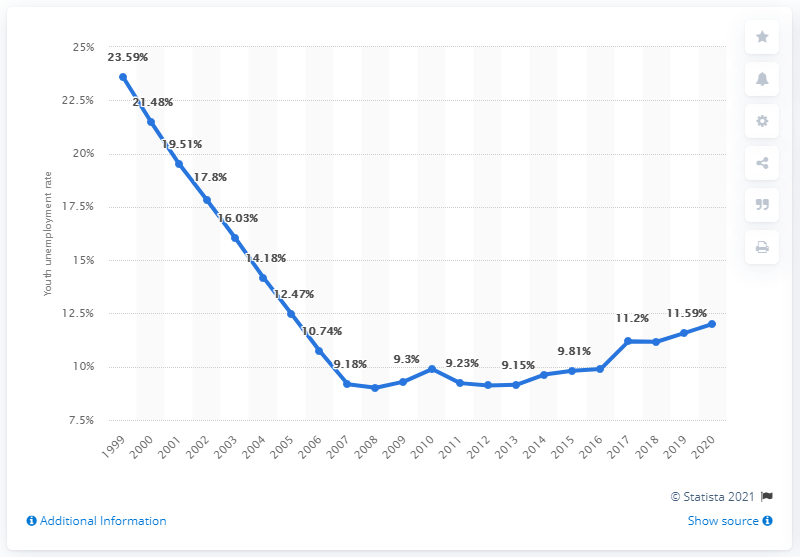Give some essential details in this illustration. The youth unemployment rate in Uzbekistan in 2020 was 12.01%. 